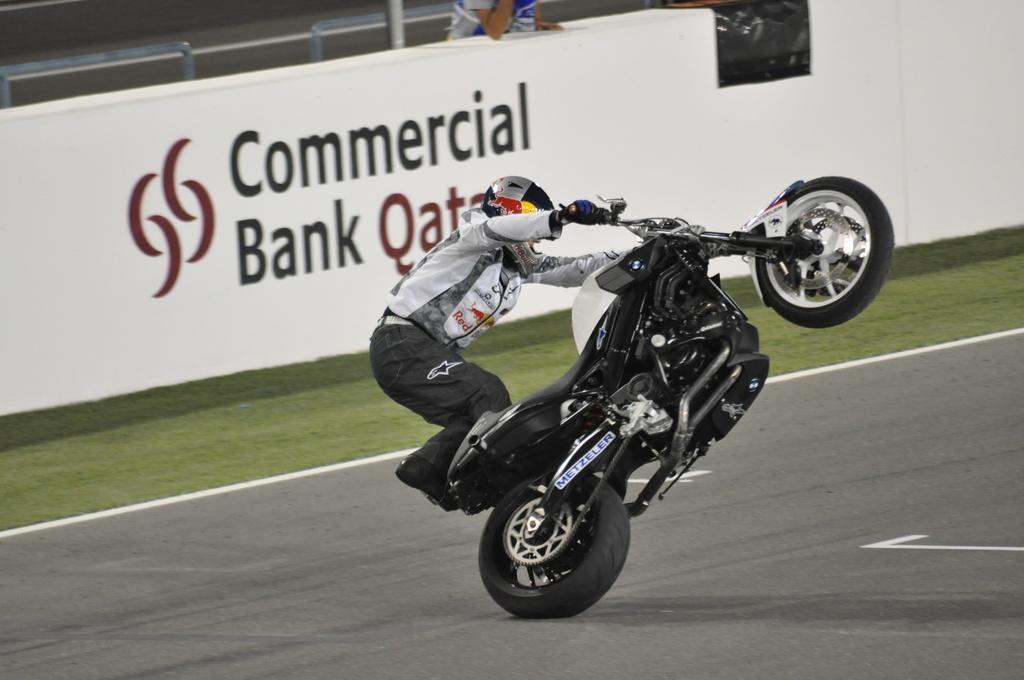Can you describe this image briefly? In this image we can see a person wearing helmet and glove is doing bike stunt. In the back there is a banner with something written. Also there is a person standing. There are railings. On the ground there is grass. 